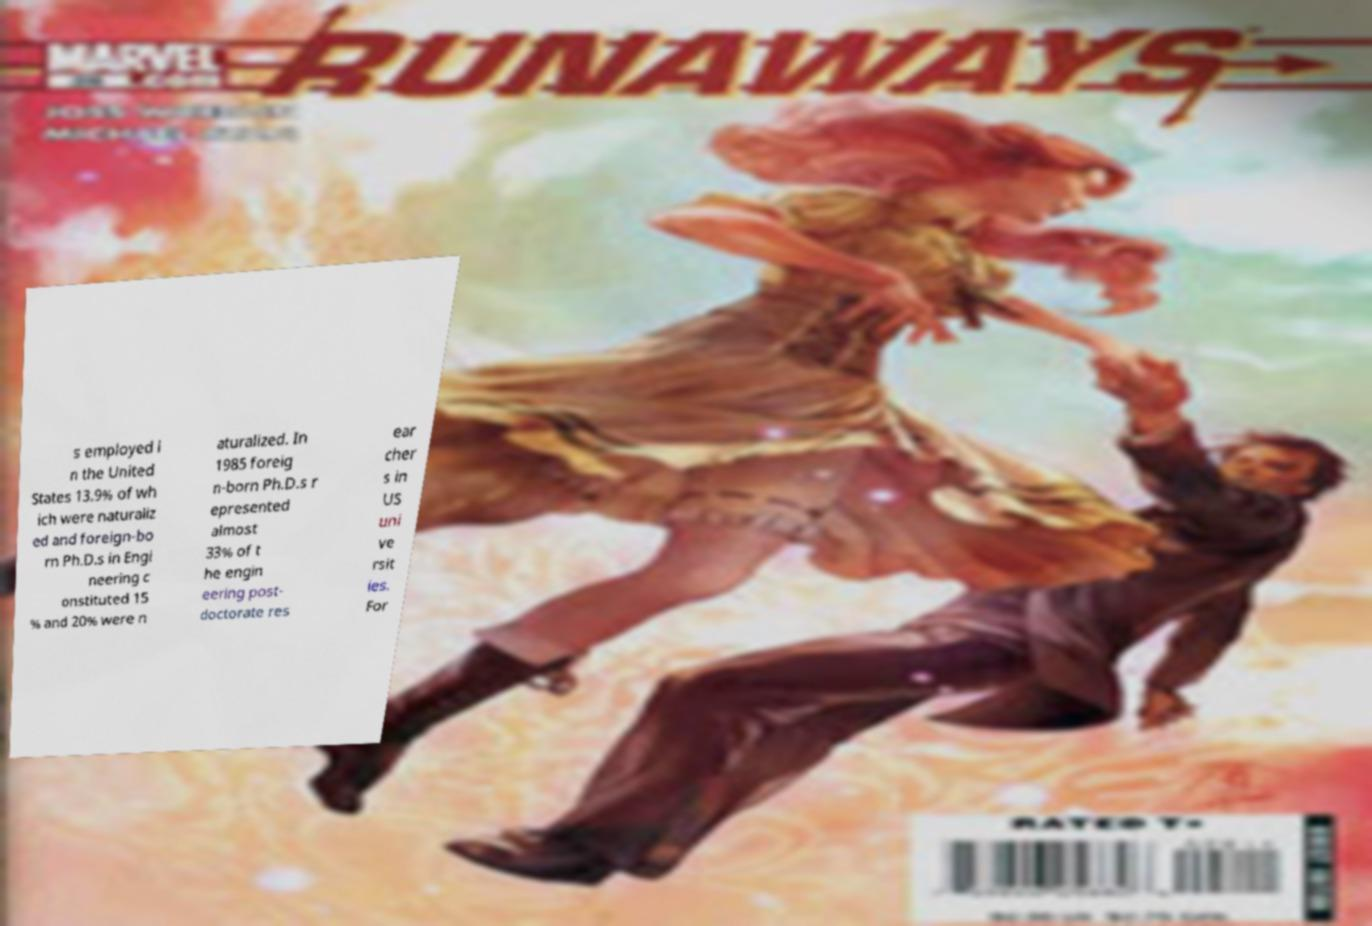Could you assist in decoding the text presented in this image and type it out clearly? s employed i n the United States 13.9% of wh ich were naturaliz ed and foreign-bo rn Ph.D.s in Engi neering c onstituted 15 % and 20% were n aturalized. In 1985 foreig n-born Ph.D.s r epresented almost 33% of t he engin eering post- doctorate res ear cher s in US uni ve rsit ies. For 